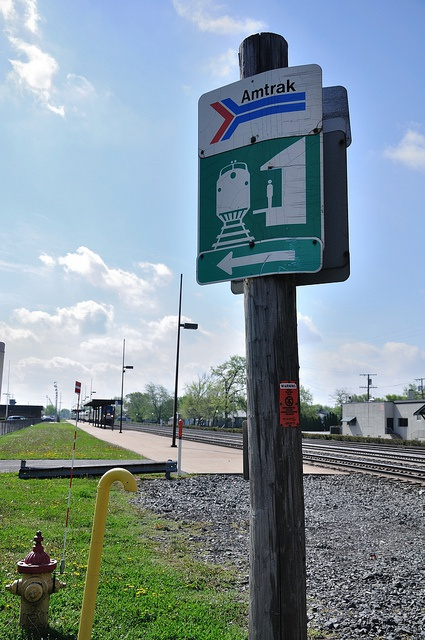Describe the objects in this image and their specific colors. I can see fire hydrant in white, black, darkgreen, and gray tones and train in white, black, darkgray, gray, and navy tones in this image. 